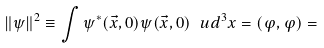<formula> <loc_0><loc_0><loc_500><loc_500>\| \psi \| ^ { 2 } \equiv \int \psi ^ { * } ( \vec { x } , 0 ) \psi ( \vec { x } , 0 ) \, { \ u d } ^ { 3 } { x } = ( \varphi , \varphi ) =</formula> 